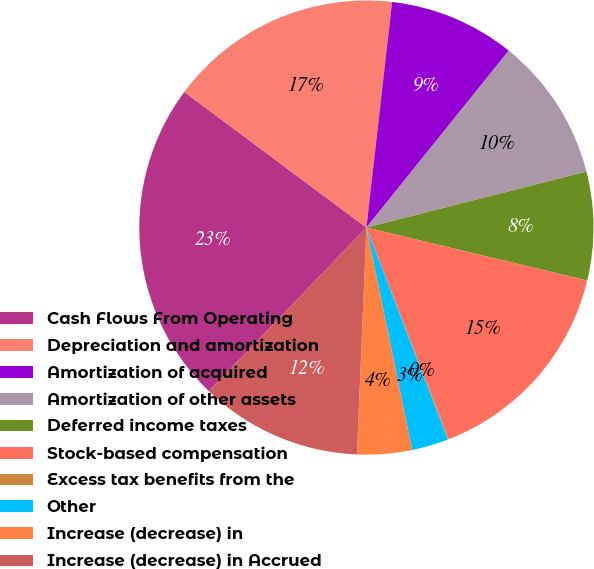<chart> <loc_0><loc_0><loc_500><loc_500><pie_chart><fcel>Cash Flows From Operating<fcel>Depreciation and amortization<fcel>Amortization of acquired<fcel>Amortization of other assets<fcel>Deferred income taxes<fcel>Stock-based compensation<fcel>Excess tax benefits from the<fcel>Other<fcel>Increase (decrease) in<fcel>Increase (decrease) in Accrued<nl><fcel>22.99%<fcel>16.62%<fcel>8.98%<fcel>10.25%<fcel>7.71%<fcel>15.35%<fcel>0.07%<fcel>2.61%<fcel>3.89%<fcel>11.53%<nl></chart> 